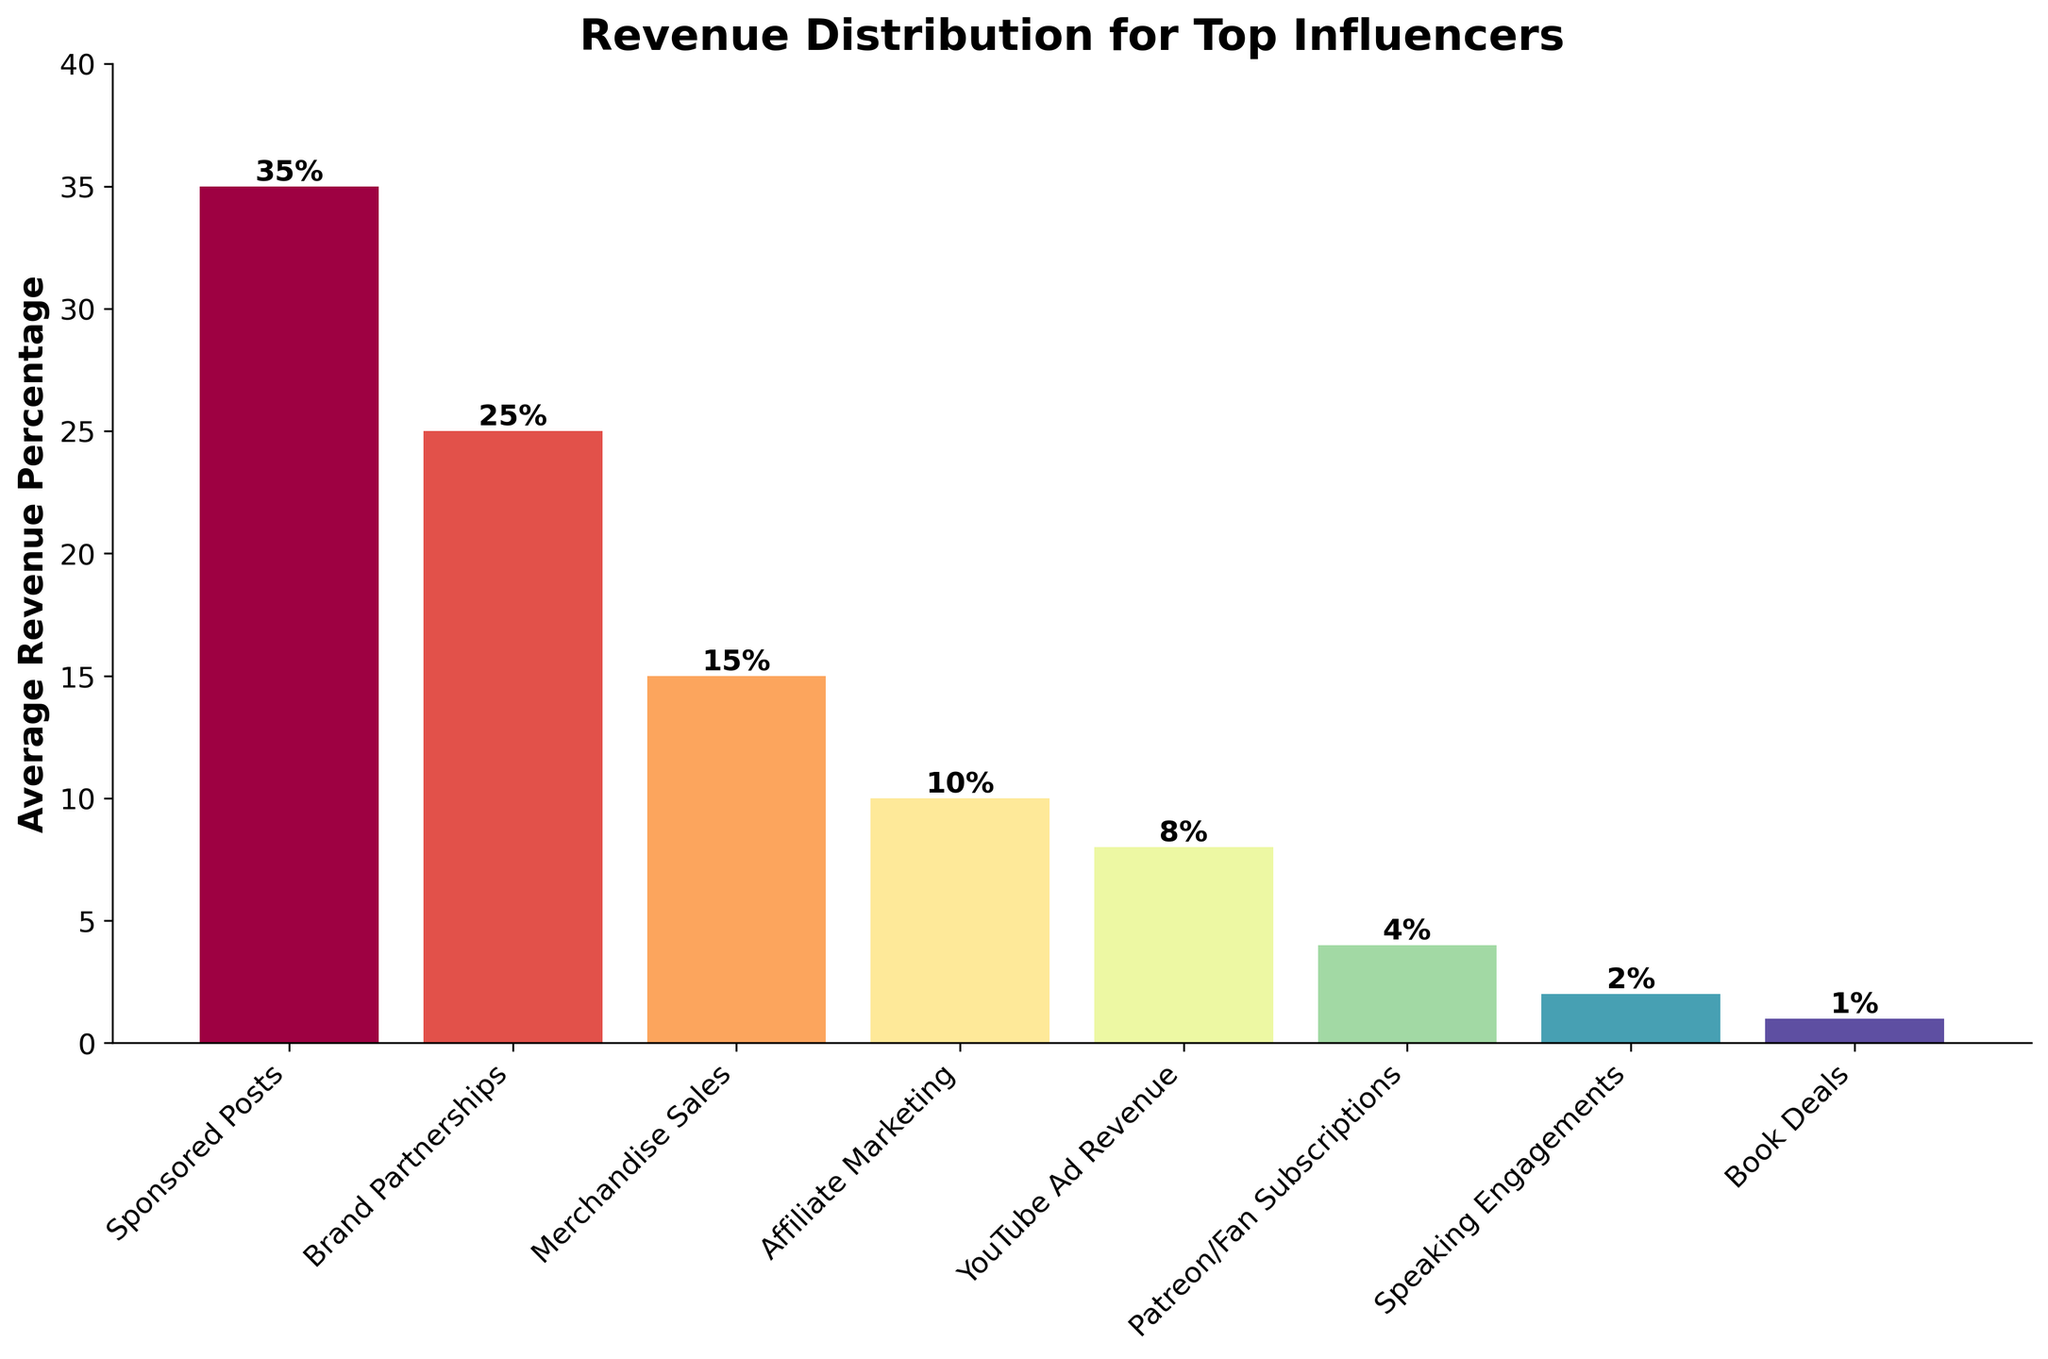Which income stream generates the highest average revenue percentage for top influencers? The bar chart shows different income streams with their respective average revenue percentages. The tallest bar represents the income stream with the highest percentage. In this case, Sponsored Posts has the highest bar at 35%.
Answer: Sponsored Posts What is the combined revenue percentage from Merchandise Sales and Affiliate Marketing? To find the combined revenue percentage, look at the heights of the bars for Merchandise Sales and Affiliate Marketing and add them together. Merchandise Sales is at 15% and Affiliate Marketing is at 10%. So, 15% + 10% = 25%.
Answer: 25% How much higher is the average revenue percentage from YouTube Ad Revenue compared to Speaking Engagements? To find this, look at the heights of the bars for YouTube Ad Revenue and Speaking Engagements. YouTube Ad Revenue is at 8% and Speaking Engagements is at 2%. The difference is 8% - 2% = 6%.
Answer: 6% Rank the income streams from highest to lowest average revenue percentage. Observing the heights of the bars, list the income streams in descending order based on their percentages: Sponsored Posts (35%), Brand Partnerships (25%), Merchandise Sales (15%), Affiliate Marketing (10%), YouTube Ad Revenue (8%), Patreon/Fan Subscriptions (4%), Speaking Engagements (2%), Book Deals (1%).
Answer: Sponsored Posts, Brand Partnerships, Merchandise Sales, Affiliate Marketing, YouTube Ad Revenue, Patreon/Fan Subscriptions, Speaking Engagements, Book Deals What is the sum of the revenue percentages from income streams that each contribute 10% or less? Identify the bars that have percentages 10% or less: Affiliate Marketing (10%), YouTube Ad Revenue (8%), Patreon/Fan Subscriptions (4%), Speaking Engagements (2%), Book Deals (1%). Add them together: 10% + 8% + 4% + 2% + 1% = 25%.
Answer: 25% Which income stream contributes equally to YouTube Ad Revenue and how much is it? Look at the height of the bar for YouTube Ad Revenue, which is at 8%, and find another bar of the same height. However, in this chart, no other income stream matches it exactly in percentage. Therefore, no other income stream contributes equally.
Answer: None Compare the heights of the bars for Sponsored Posts and Book Deals. How many times more is the average revenue percentage from Sponsored Posts compared to Book Deals? The bar for Sponsored Posts is at 35% and for Book Deals is at 1%. To find how many times more, divide the height of Sponsored Posts by the height of Book Deals: 35% / 1% = 35 times.
Answer: 35 times What is the difference in revenue percentage between the highest and lowest income streams? The highest income stream is Sponsored Posts at 35% and the lowest is Book Deals at 1%. The difference is 35% - 1% = 34%.
Answer: 34% Identify the income streams that contribute a total of more than 50% when combined. To exceed 50%, start adding the highest percentages: Sponsored Posts (35%) + Brand Partnerships (25%) = 60%. As adding these two streams already goes beyond 50%, no need to include more.
Answer: Sponsored Posts and Brand Partnerships 